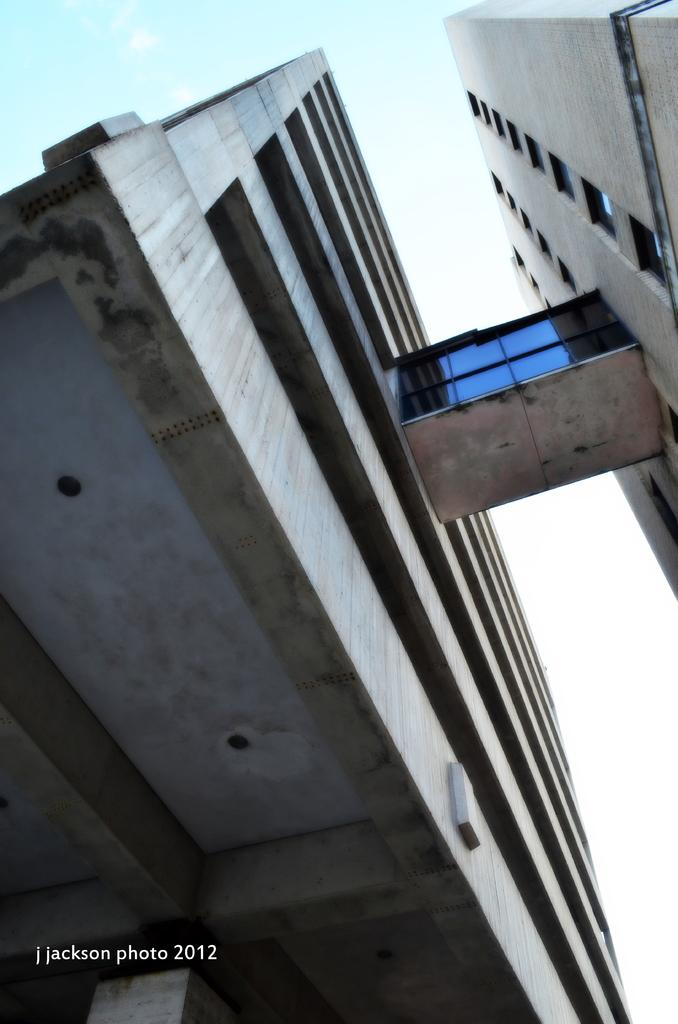What type of structures can be seen in the image? There are buildings in the image. What part of the natural environment is visible in the image? The sky is visible in the image. What type of locket is hanging from the roof of the building in the image? There is no locket present in the image, and the image does not show any roofs of buildings. 